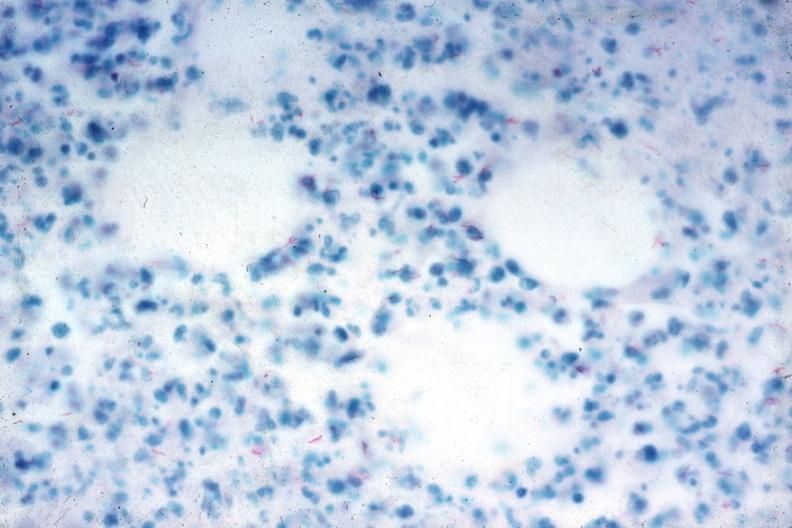do acid stain stain numerous acid fast bacilli very good slide?
Answer the question using a single word or phrase. Yes 